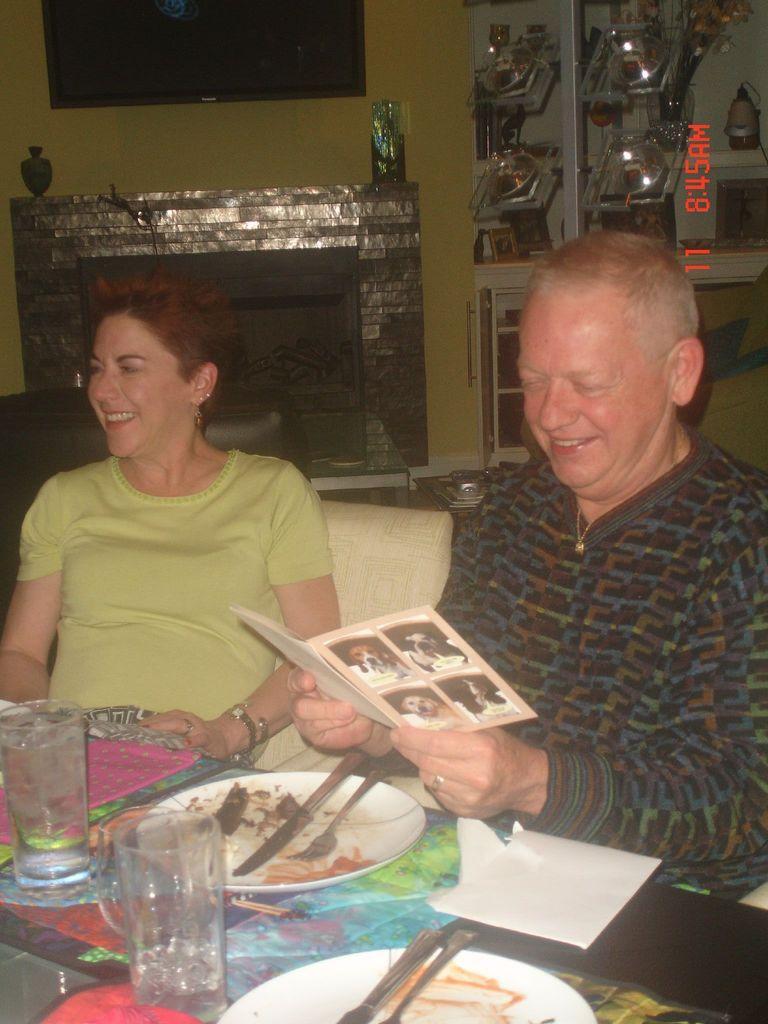Could you give a brief overview of what you see in this image? In this image we can see two persons sitting in front of a table. One women is wearing a green t shirt and other person is holding a book in his hands. On the table there are set of glasses ,group of plates ,spoons placed on the table. In the background we can see a television on the wall and some shields are placed on the cupboard. 